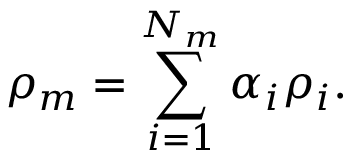Convert formula to latex. <formula><loc_0><loc_0><loc_500><loc_500>\rho _ { m } = \sum _ { i = 1 } ^ { N _ { m } } \alpha _ { i } \rho _ { i } .</formula> 